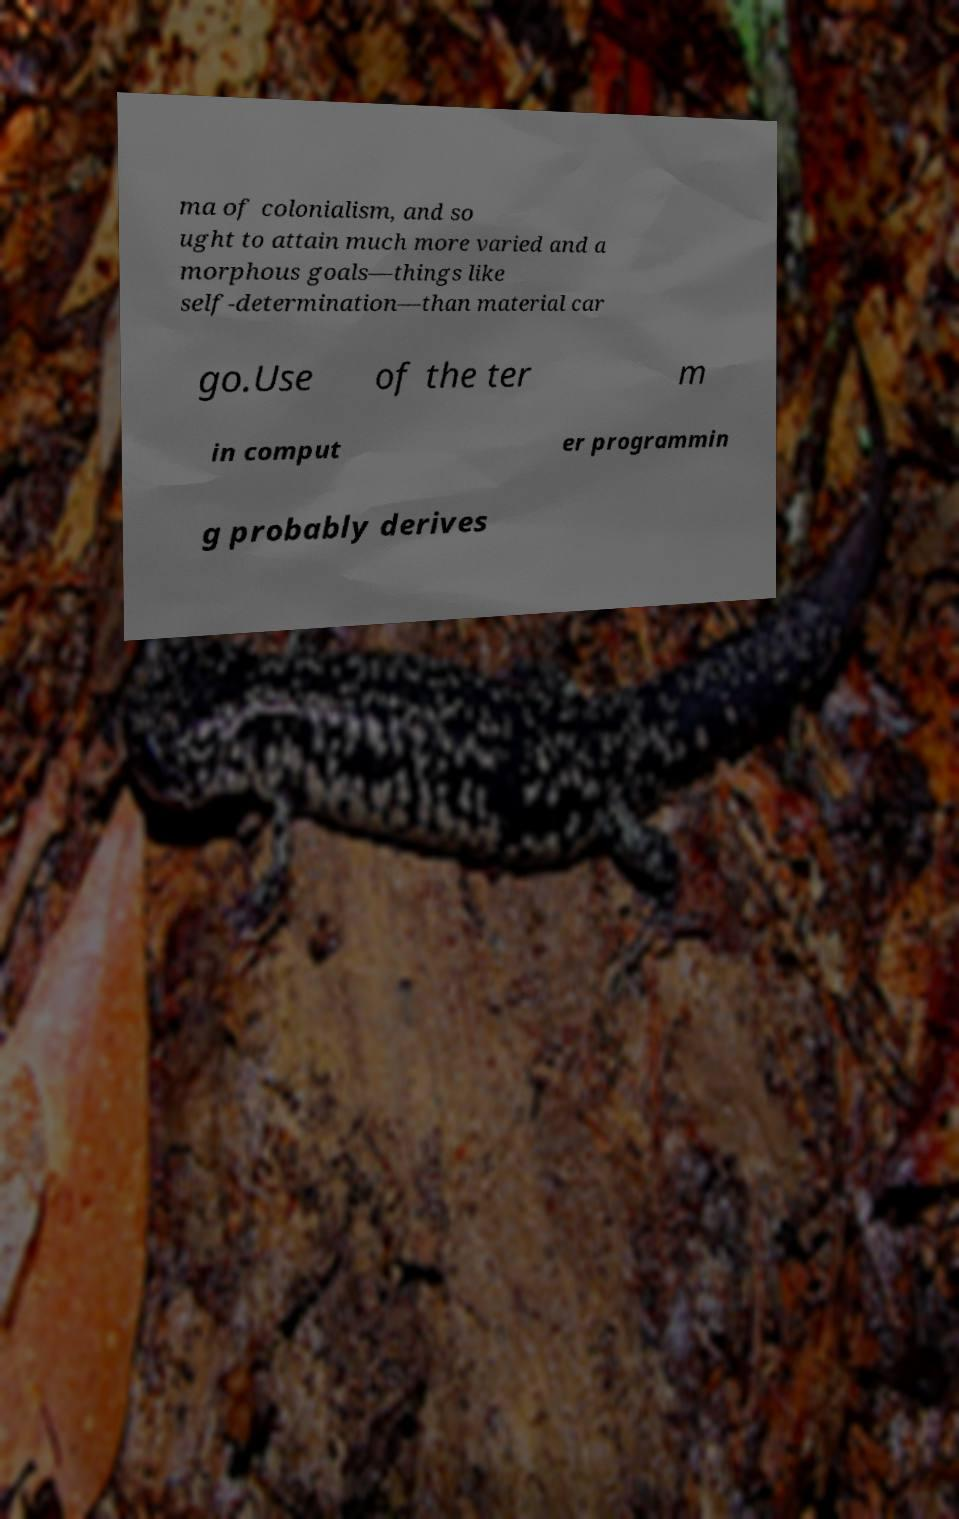For documentation purposes, I need the text within this image transcribed. Could you provide that? ma of colonialism, and so ught to attain much more varied and a morphous goals—things like self-determination—than material car go.Use of the ter m in comput er programmin g probably derives 